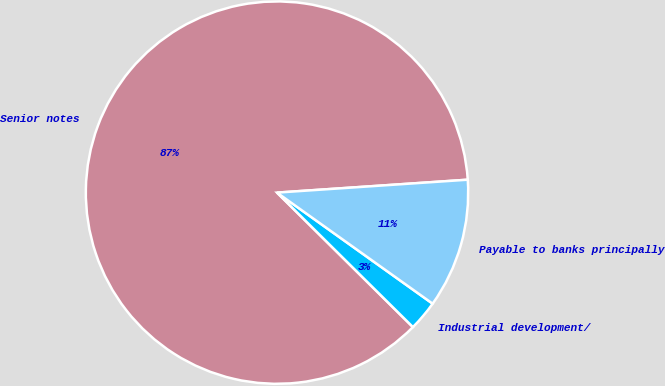Convert chart. <chart><loc_0><loc_0><loc_500><loc_500><pie_chart><fcel>Senior notes<fcel>Industrial development/<fcel>Payable to banks principally<nl><fcel>86.51%<fcel>2.55%<fcel>10.94%<nl></chart> 